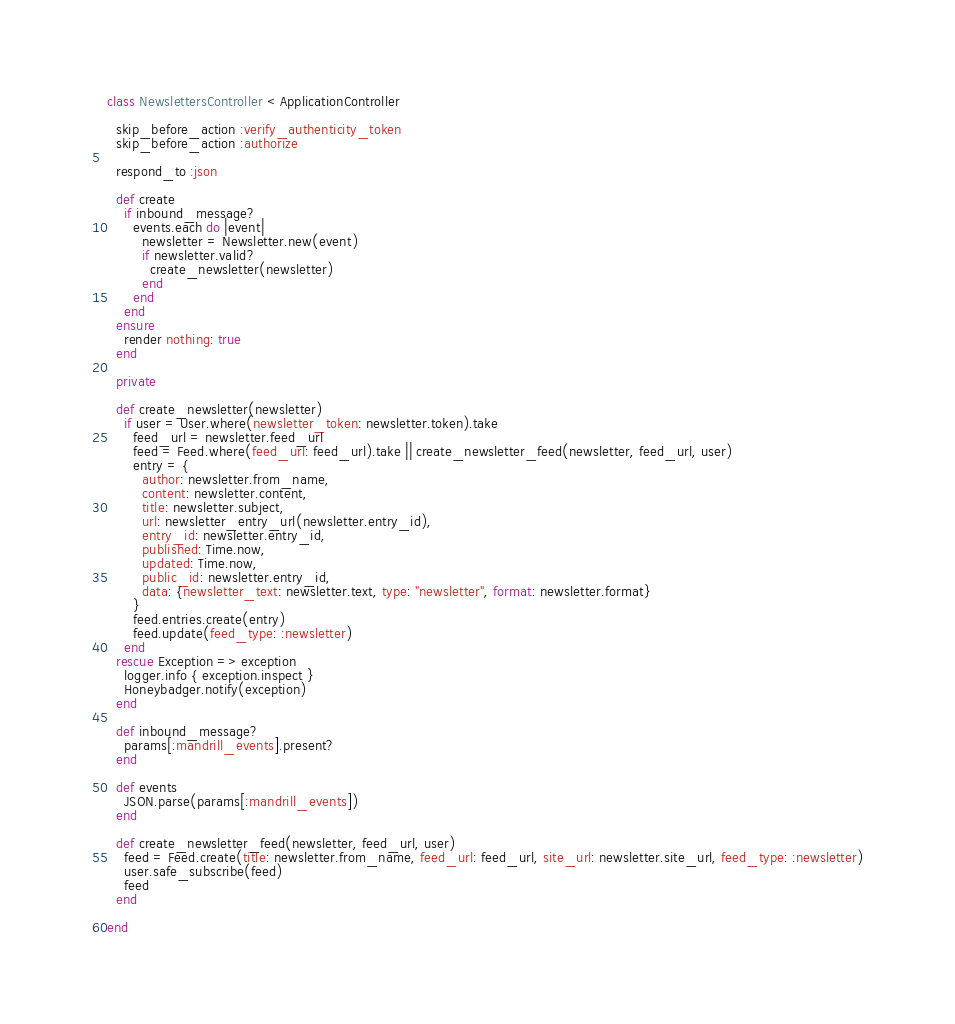<code> <loc_0><loc_0><loc_500><loc_500><_Ruby_>class NewslettersController < ApplicationController

  skip_before_action :verify_authenticity_token
  skip_before_action :authorize

  respond_to :json

  def create
    if inbound_message?
      events.each do |event|
        newsletter = Newsletter.new(event)
        if newsletter.valid?
          create_newsletter(newsletter)
        end
      end
    end
  ensure
    render nothing: true
  end

  private

  def create_newsletter(newsletter)
    if user = User.where(newsletter_token: newsletter.token).take
      feed_url = newsletter.feed_url
      feed = Feed.where(feed_url: feed_url).take || create_newsletter_feed(newsletter, feed_url, user)
      entry = {
        author: newsletter.from_name,
        content: newsletter.content,
        title: newsletter.subject,
        url: newsletter_entry_url(newsletter.entry_id),
        entry_id: newsletter.entry_id,
        published: Time.now,
        updated: Time.now,
        public_id: newsletter.entry_id,
        data: {newsletter_text: newsletter.text, type: "newsletter", format: newsletter.format}
      }
      feed.entries.create(entry)
      feed.update(feed_type: :newsletter)
    end
  rescue Exception => exception
    logger.info { exception.inspect }
    Honeybadger.notify(exception)
  end

  def inbound_message?
    params[:mandrill_events].present?
  end

  def events
    JSON.parse(params[:mandrill_events])
  end

  def create_newsletter_feed(newsletter, feed_url, user)
    feed = Feed.create(title: newsletter.from_name, feed_url: feed_url, site_url: newsletter.site_url, feed_type: :newsletter)
    user.safe_subscribe(feed)
    feed
  end

end


</code> 